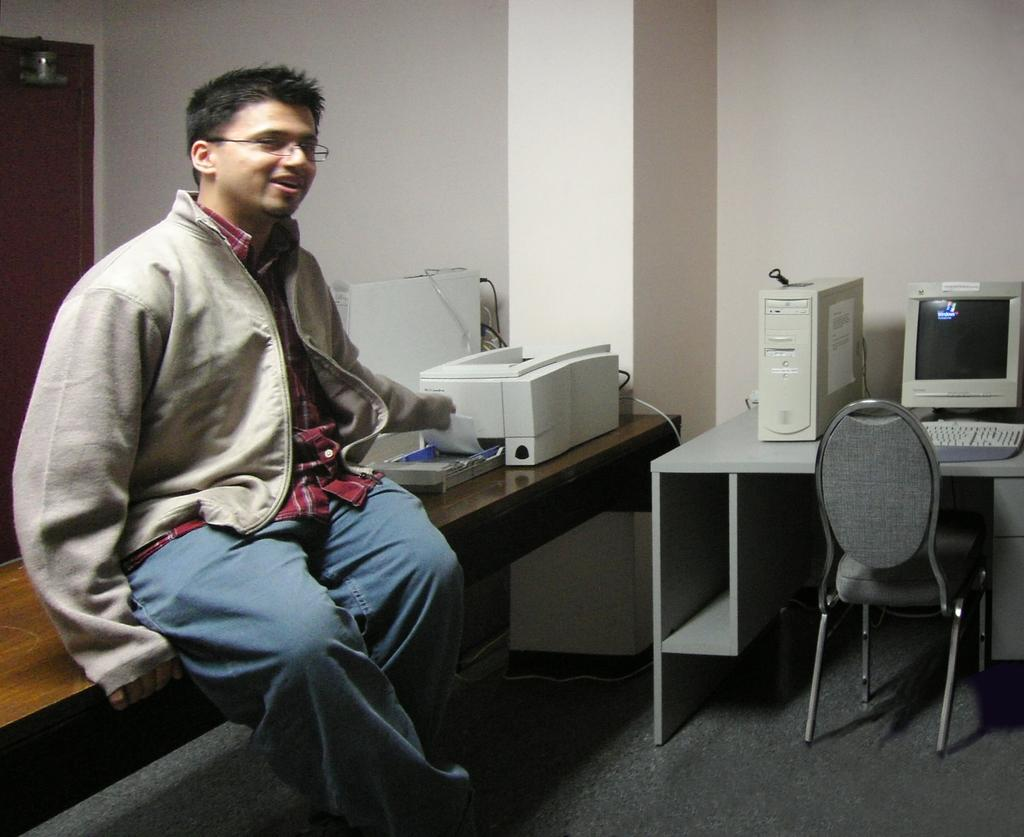What is the man in the image doing? The man is sitting on a table in the image. What can be seen on the man's face in the image? The man is wearing glasses (specs) in the image. What is visible in the background of the image? There is a computer system and a chair in the background of the image. How far away is the star from the man in the image? There is no star visible in the image, so it is not possible to determine the distance between the man and a star. 